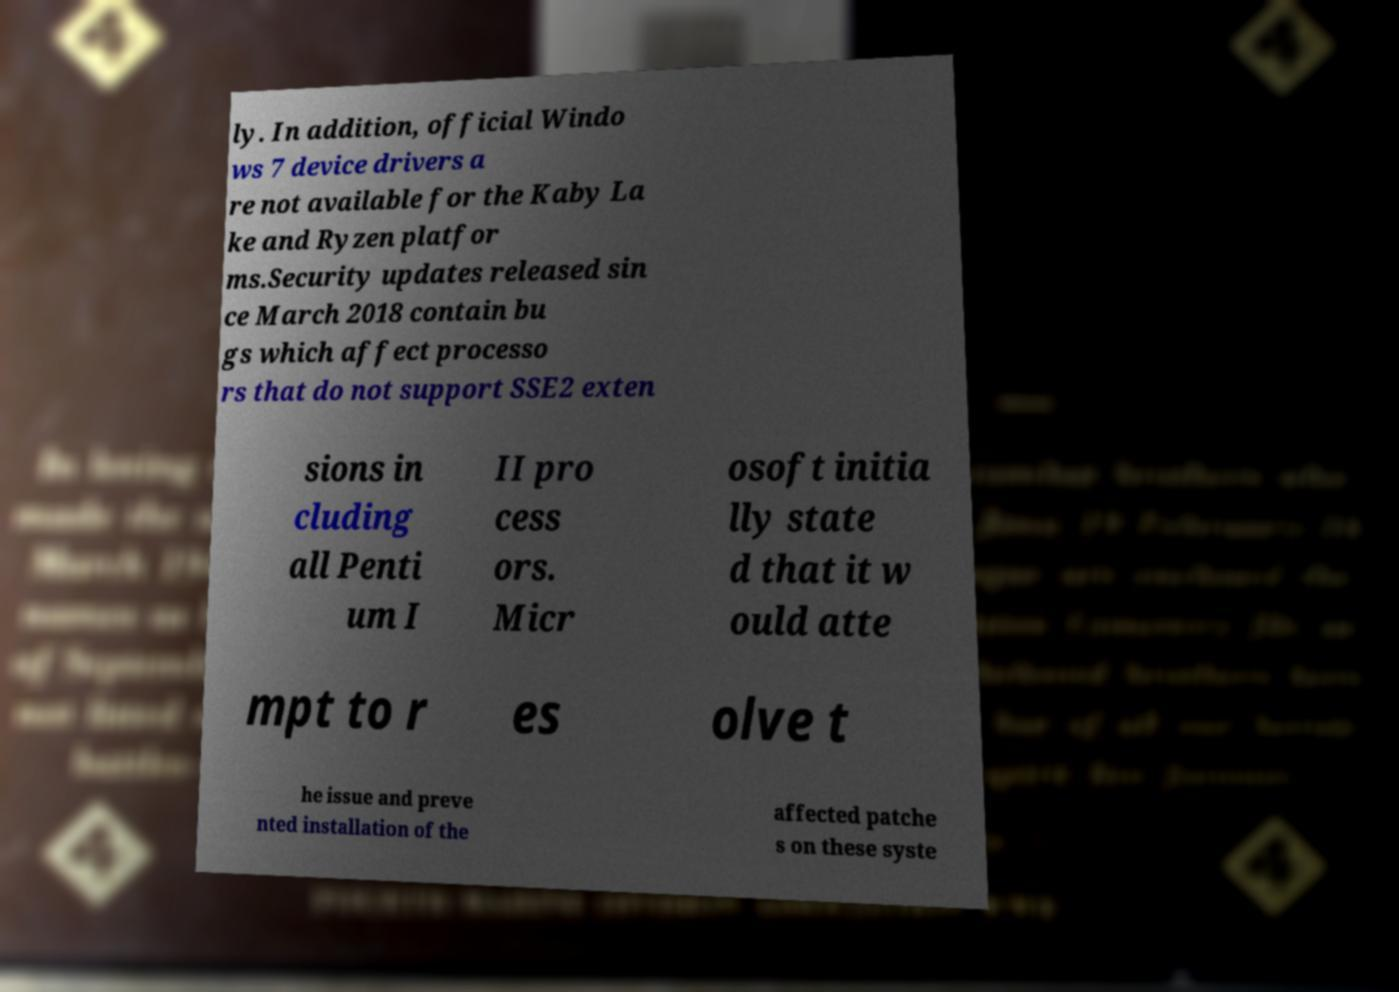What messages or text are displayed in this image? I need them in a readable, typed format. ly. In addition, official Windo ws 7 device drivers a re not available for the Kaby La ke and Ryzen platfor ms.Security updates released sin ce March 2018 contain bu gs which affect processo rs that do not support SSE2 exten sions in cluding all Penti um I II pro cess ors. Micr osoft initia lly state d that it w ould atte mpt to r es olve t he issue and preve nted installation of the affected patche s on these syste 